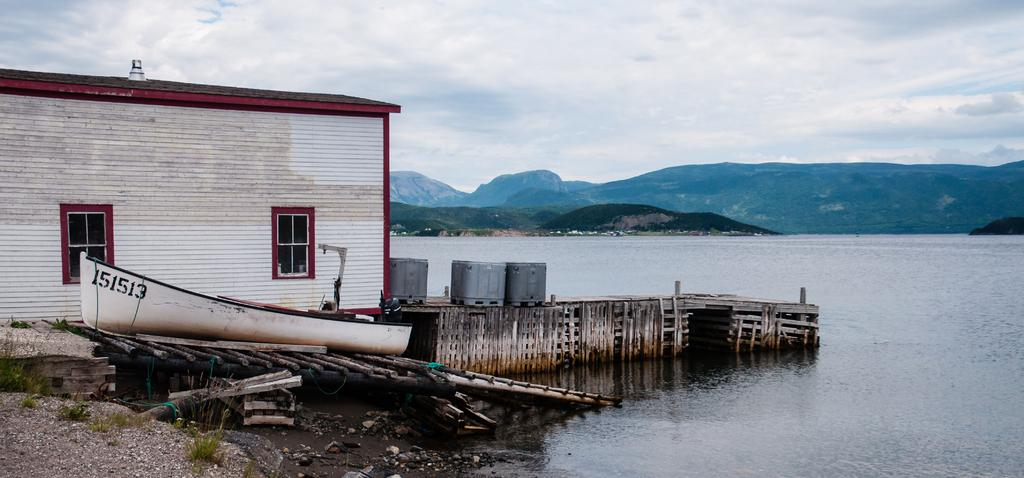What color is the building in the image? The building in the image is white-colored. What feature does the building have? The building has windows. What is another white-colored object in the image? There is a white-colored boat in the image. What type of terrain is visible in the image? Grass is visible in the image. What natural element is present in the image? There is water in the image. What type of objects are grey-colored in the image? There are grey-colored boxes in the image. What can be seen in the background of the image? There are clouds and the sky visible in the background of the image. Can you describe the reaction of the chain when it falls into the water in the image? There is no chain present in the image, so it is not possible to describe any reaction. 